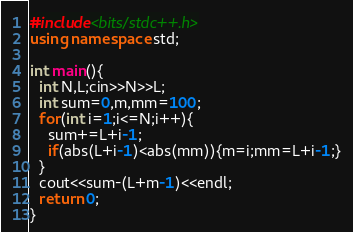Convert code to text. <code><loc_0><loc_0><loc_500><loc_500><_C++_>#include<bits/stdc++.h>
using namespace std;

int main(){
  int N,L;cin>>N>>L;
  int sum=0,m,mm=100;
  for(int i=1;i<=N;i++){
    sum+=L+i-1;
    if(abs(L+i-1)<abs(mm)){m=i;mm=L+i-1;}
  }
  cout<<sum-(L+m-1)<<endl;
  return 0;
}</code> 